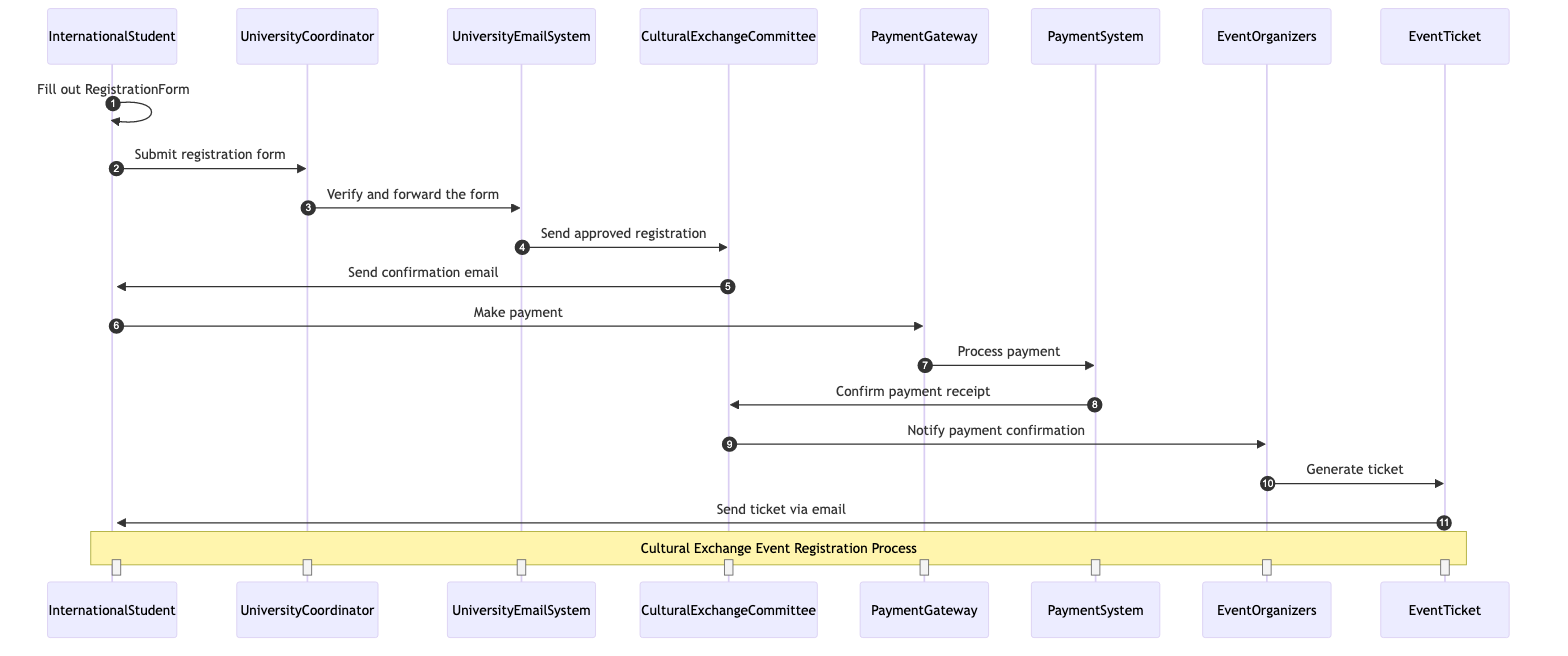What is the first action taken by the International Student? The International Student starts the process by filling out the Registration Form, as indicated by the first interaction in the diagram.
Answer: Fill out Registration Form How many actors are involved in the registration process? The diagram includes six unique actors: International Student, University Coordinator, University Email System, Cultural Exchange Committee, Payment Gateway, Payment System, and Event Organizers.
Answer: Six What action does the University Coordinator take after receiving the registration form? The University Coordinator verifies and forwards the registration form to the University Email System, which is the next step indicated in the diagram.
Answer: Verify and forward the form Who sends the confirmation email to the International Student? The Cultural Exchange Committee sends the confirmation email to the International Student, as shown in the flow of interactions.
Answer: Cultural Exchange Committee What happens after the International Student makes the payment? After making the payment, the Payment Gateway processes the payment, followed by the Payment System confirming the payment receipt to the Cultural Exchange Committee.
Answer: Process payment Which object is generated by the Event Organizers? The Event Ticket is generated by the Event Organizers after they receive notification of payment confirmation from the Cultural Exchange Committee.
Answer: Event Ticket What is the role of the Payment System in the sequence? The Payment System processes the payment made by the International Student through the Payment Gateway and confirms the payment receipt to the Cultural Exchange Committee.
Answer: Process payment How many steps are there from filling out the registration form to receiving the event ticket? The sequence consists of ten separate steps starting from filling out the registration form until the International Student receives the event ticket via email.
Answer: Ten What is the last action in the sequence diagram? The last action in the sequence is the sending of the event ticket via email to the International Student, marking the conclusion of the registration process.
Answer: Send ticket via email 